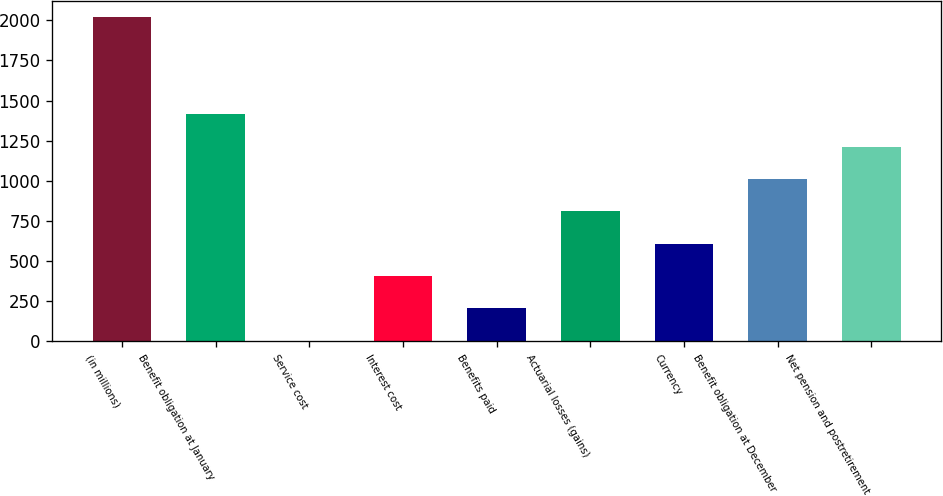<chart> <loc_0><loc_0><loc_500><loc_500><bar_chart><fcel>(in millions)<fcel>Benefit obligation at January<fcel>Service cost<fcel>Interest cost<fcel>Benefits paid<fcel>Actuarial losses (gains)<fcel>Currency<fcel>Benefit obligation at December<fcel>Net pension and postretirement<nl><fcel>2018<fcel>1413.8<fcel>4<fcel>406.8<fcel>205.4<fcel>809.6<fcel>608.2<fcel>1011<fcel>1212.4<nl></chart> 